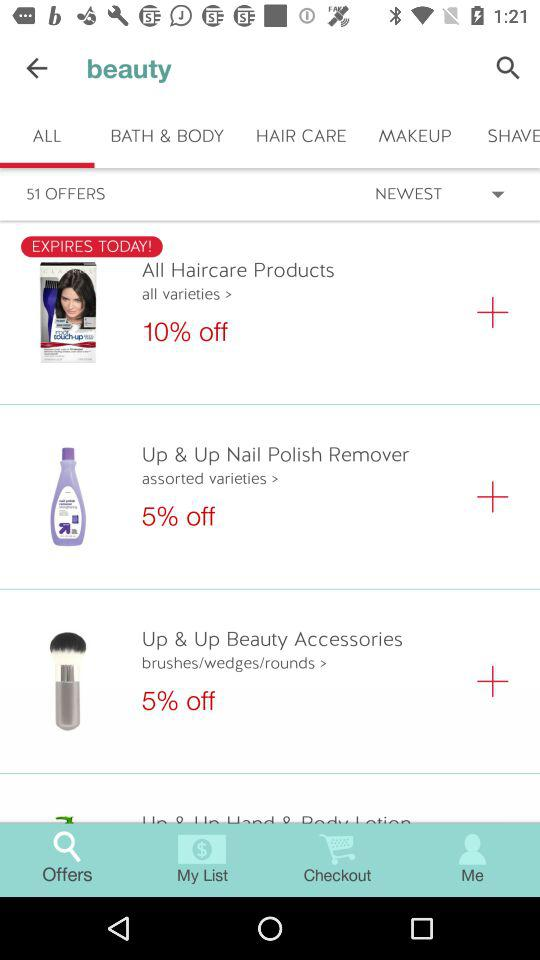How much is the discount offered on "Up & Up Beauty Accessories"? The offered discount is 5% on "Up & Up Beauty Accessories". 